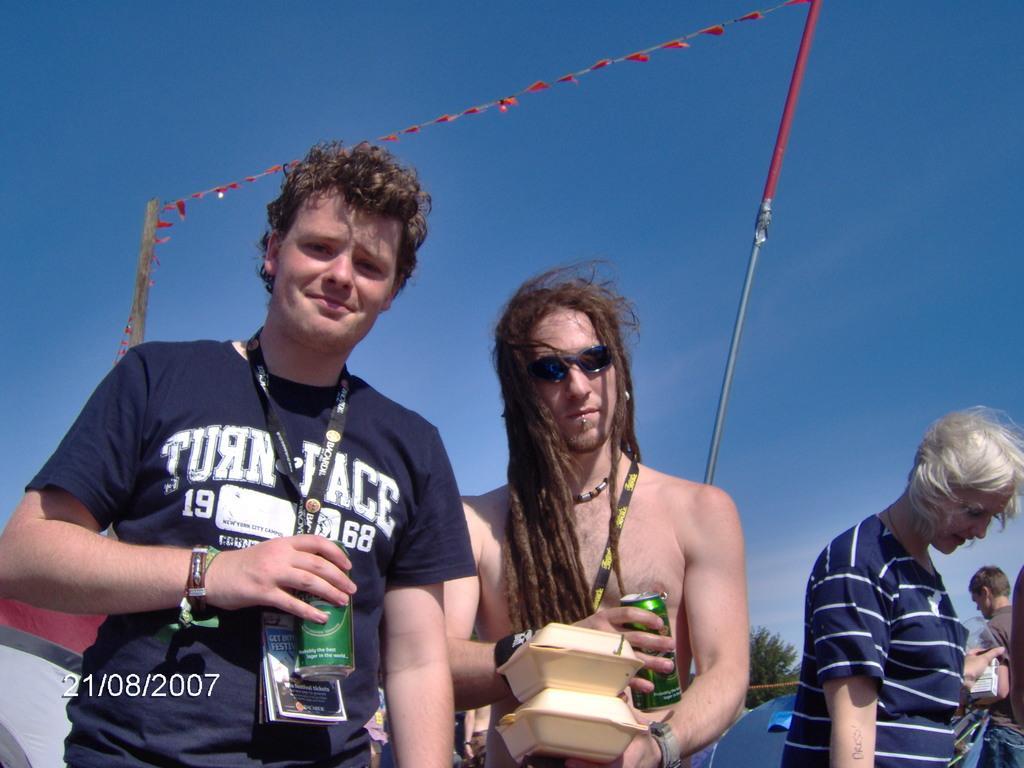Could you give a brief overview of what you see in this image? In this image I can see a person wearing blue colored t shirt is standing and holding an object in his hand and another person is holding a green colored tin and few other objects in his hands. In the background I can see few other persons standing, few poles, few red colored flags, the sky and few trees. 